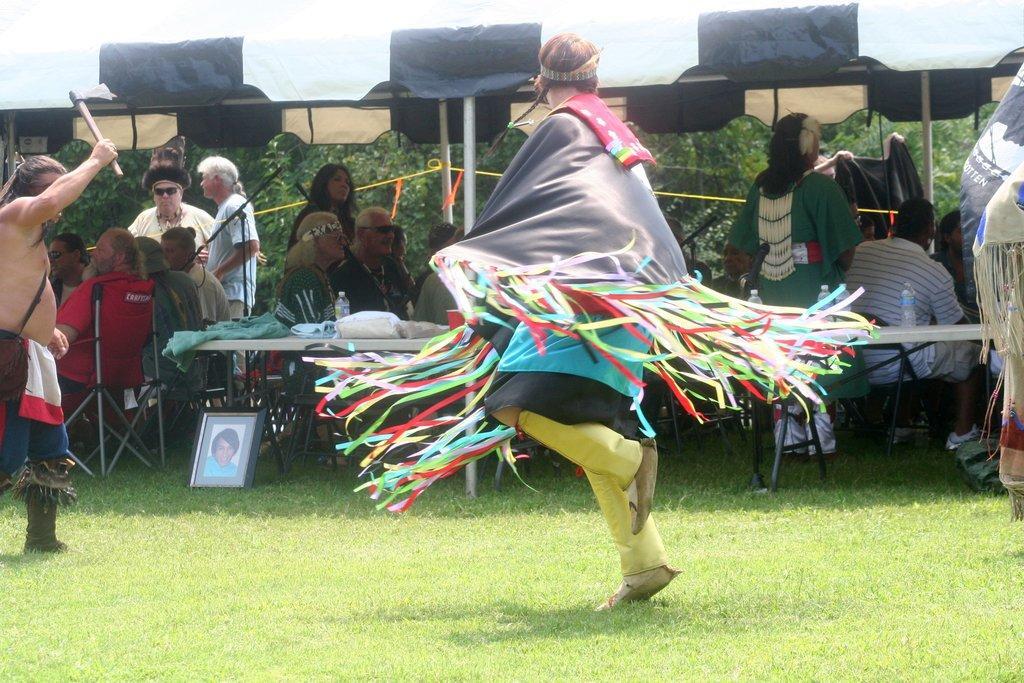Please provide a concise description of this image. In this image we can see persons sitting on the chairs and standing on the ground. There is a table placed on the ground on that there are clothes, photo frames, disposable bottles and polythene covers. In the background we can see trees. 